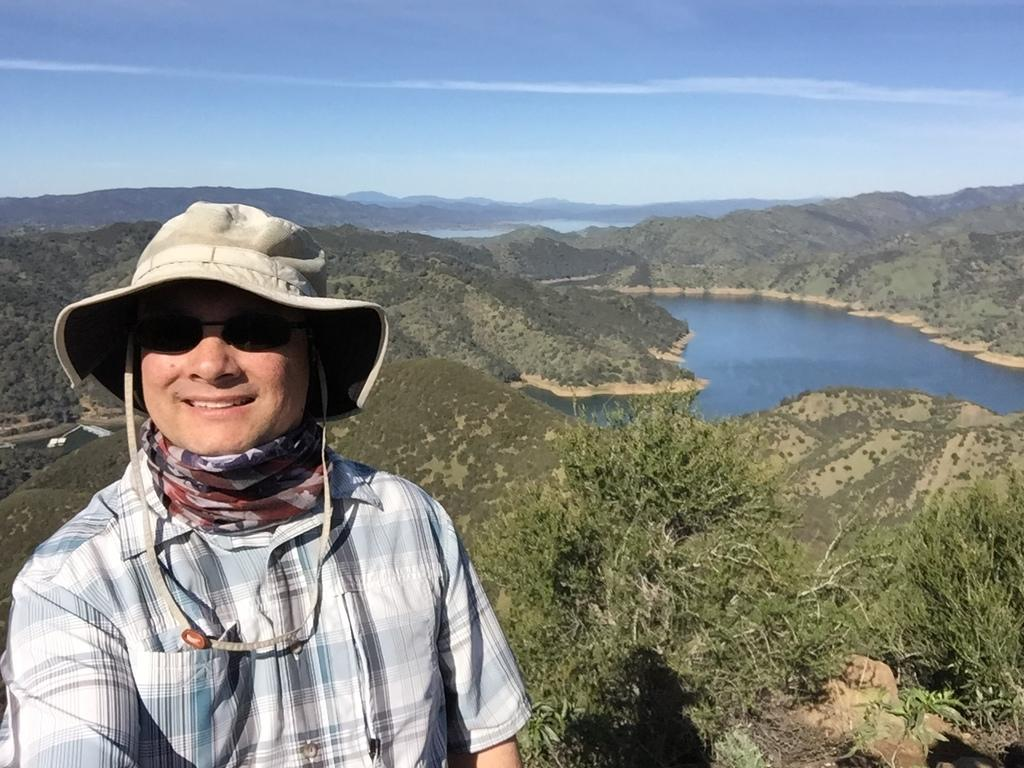What type of landscape is depicted in the image? The image features hills and trees. What natural elements can be seen in the image? Water and the sky are visible in the image. Is there any human presence in the image? Yes, there is a person standing in the front of the image. What type of vehicle is the person driving in the image? There is no vehicle present in the image; the person is standing. What type of gold object is the servant holding in the image? There is no servant or gold object present in the image. 